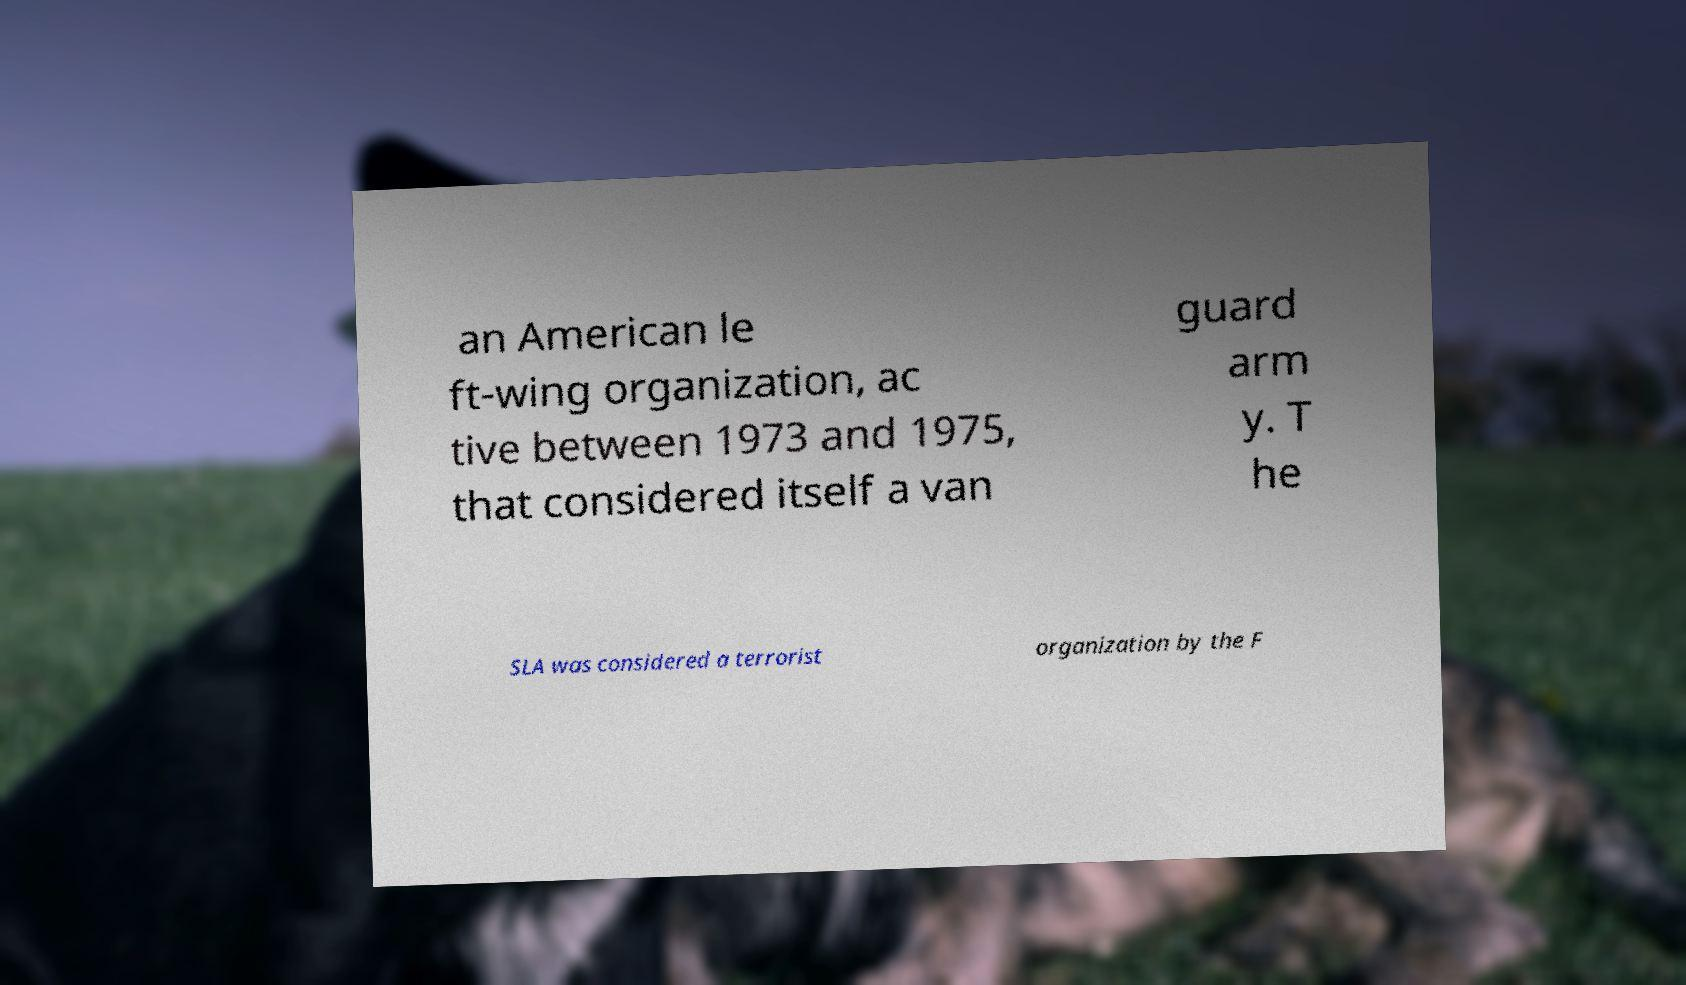There's text embedded in this image that I need extracted. Can you transcribe it verbatim? an American le ft-wing organization, ac tive between 1973 and 1975, that considered itself a van guard arm y. T he SLA was considered a terrorist organization by the F 